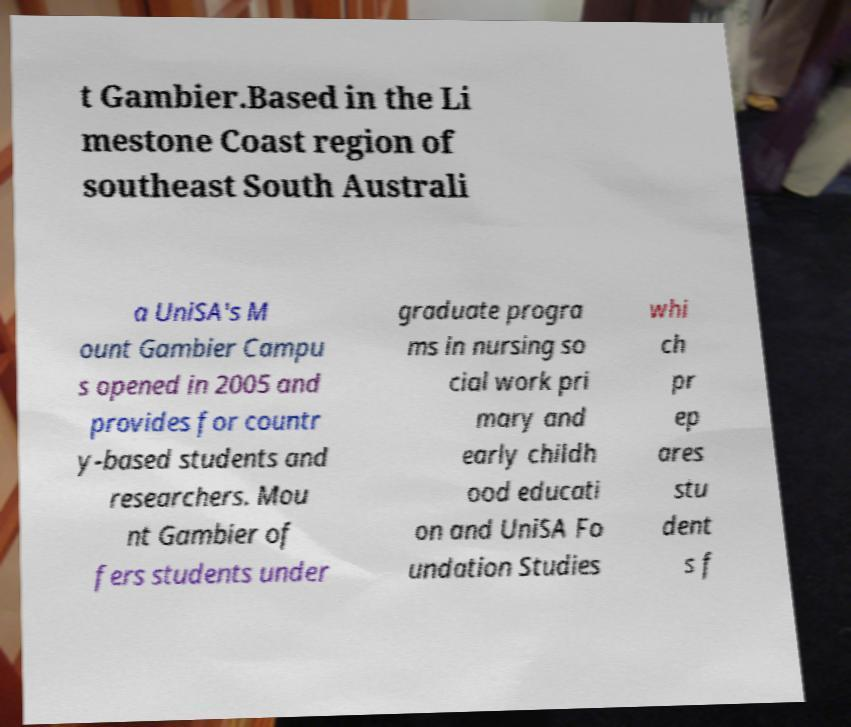Can you read and provide the text displayed in the image?This photo seems to have some interesting text. Can you extract and type it out for me? t Gambier.Based in the Li mestone Coast region of southeast South Australi a UniSA's M ount Gambier Campu s opened in 2005 and provides for countr y-based students and researchers. Mou nt Gambier of fers students under graduate progra ms in nursing so cial work pri mary and early childh ood educati on and UniSA Fo undation Studies whi ch pr ep ares stu dent s f 